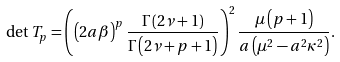<formula> <loc_0><loc_0><loc_500><loc_500>\det T _ { p } = \left ( \left ( 2 a \beta \right ) ^ { p } \frac { \Gamma \left ( 2 \nu + 1 \right ) } { \Gamma \left ( 2 \nu + p + 1 \right ) } \right ) ^ { 2 } \frac { \mu \left ( p + 1 \right ) } { a \left ( \mu ^ { 2 } - a ^ { 2 } \kappa ^ { 2 } \right ) } .</formula> 